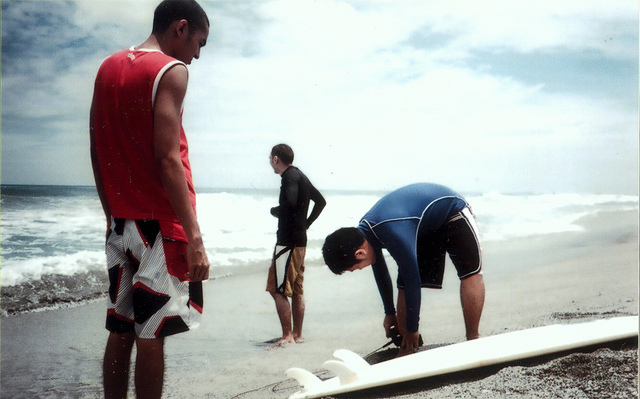How many boys are in this photo? 3 